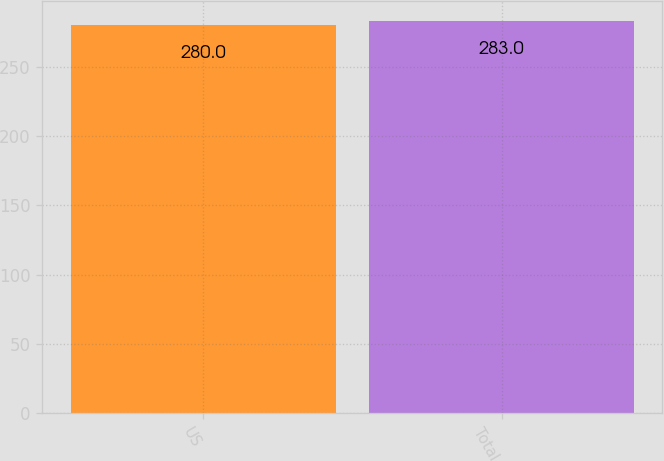<chart> <loc_0><loc_0><loc_500><loc_500><bar_chart><fcel>US<fcel>Total<nl><fcel>280<fcel>283<nl></chart> 